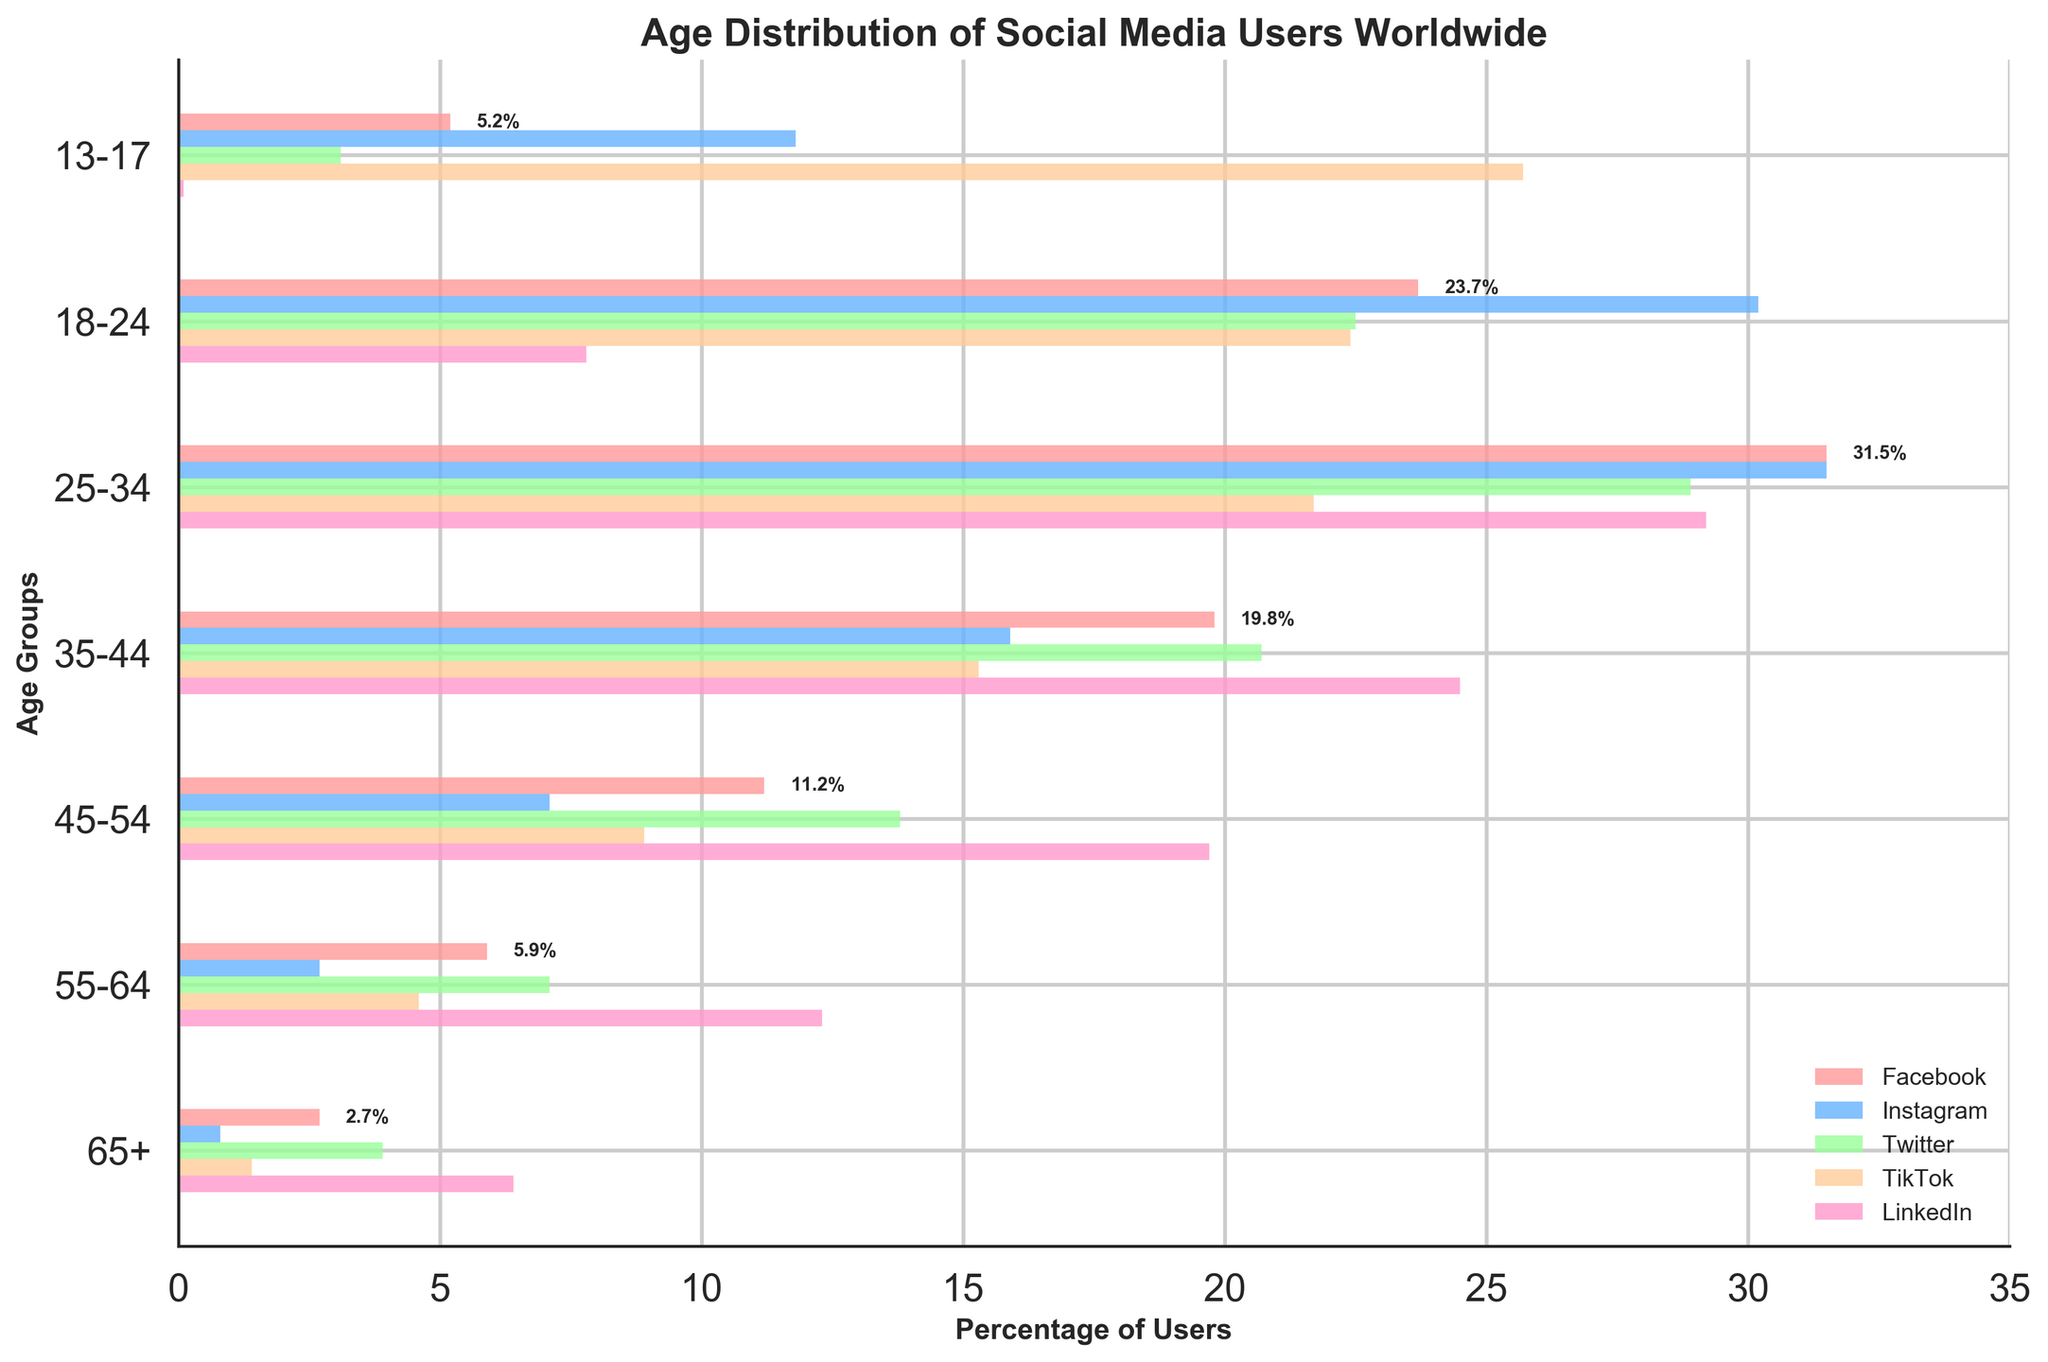What's the title of the figure? The title is usually located at the top of the figure and summarizes what the figure is about. In this case, it states 'Age Distribution of Social Media Users Worldwide'.
Answer: Age Distribution of Social Media Users Worldwide Which age group has the highest percentage of Facebook users? Look at the horizontal bars for Facebook across different age groups. The bar with the longest length represents the highest percentage.
Answer: 25-34 What is the percentage difference in Instagram users between the age groups 18-24 and 35-44? Subtract the percentage value of the 35-44 age group from that of the 18-24 age group by looking at the corresponding bars for Instagram.
Answer: 14.3% Which social media platform has the highest percentage of users aged 13-17? Compare the lengths of the bars for the age group 13-17 across all platforms. The longest bar indicates the highest percentage.
Answer: TikTok Compare the combined percentage of Twitter users in the age groups 25-34 and 35-44 with the percentage of Facebook users aged 18-24. Which is higher? Add the percentages of Twitter users in the age groups 25-34 and 35-44, then compare this sum with the percentage of Facebook users in the age group 18-24. The combined Twitter percentage is 28.9 + 20.7 = 49.6%. The Facebook percentage is 23.7%. 49.6% is higher.
Answer: Combined Twitter percentage of 49.6% How many age groups have more than 20% of their users on TikTok? Identify and count the bars representing TikTok that exceed the 20% mark in length.
Answer: 2 age groups What is the average percentage of LinkedIn users across all age groups? Add the percentage values of LinkedIn users for all age groups, then divide the sum by the number of age groups. The values are 0.1, 7.8, 29.2, 24.5, 19.7, 12.3, 6.4. The sum is 100.0, and there are 7 age groups, so the average is 100.0 / 7.
Answer: 14.3% Which platform shows the smallest percentage of users aged 65+ compared to its other age groups? Look at the percentage bars for the age group 65+ across all platforms and compare them to the other age groups within each platform.
Answer: Instagram Is there any age group where LinkedIn has a higher percentage of users than Facebook? Compare the percentage bars of Facebook and LinkedIn for each age group. In every case, the Facebook percentage is higher than LinkedIn’s.
Answer: No 